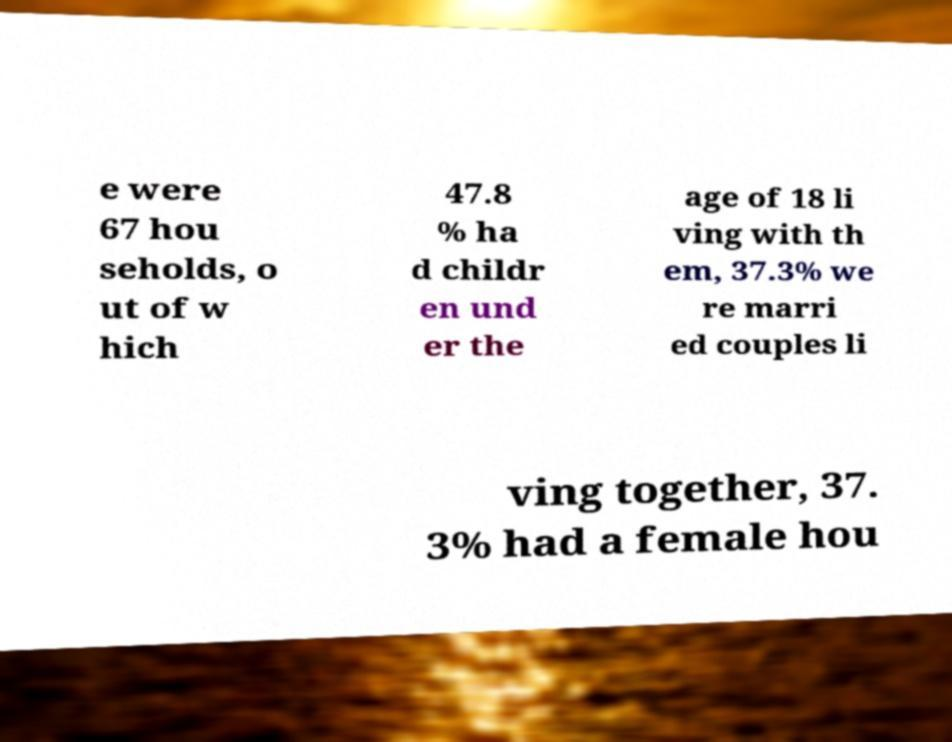Could you assist in decoding the text presented in this image and type it out clearly? e were 67 hou seholds, o ut of w hich 47.8 % ha d childr en und er the age of 18 li ving with th em, 37.3% we re marri ed couples li ving together, 37. 3% had a female hou 